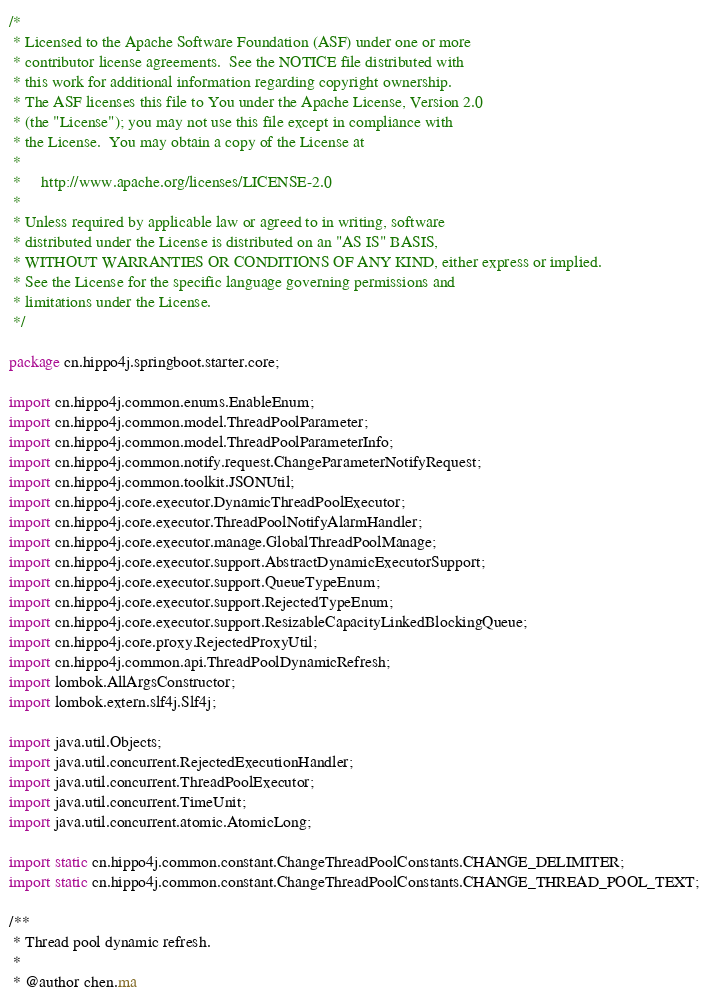Convert code to text. <code><loc_0><loc_0><loc_500><loc_500><_Java_>/*
 * Licensed to the Apache Software Foundation (ASF) under one or more
 * contributor license agreements.  See the NOTICE file distributed with
 * this work for additional information regarding copyright ownership.
 * The ASF licenses this file to You under the Apache License, Version 2.0
 * (the "License"); you may not use this file except in compliance with
 * the License.  You may obtain a copy of the License at
 *
 *     http://www.apache.org/licenses/LICENSE-2.0
 *
 * Unless required by applicable law or agreed to in writing, software
 * distributed under the License is distributed on an "AS IS" BASIS,
 * WITHOUT WARRANTIES OR CONDITIONS OF ANY KIND, either express or implied.
 * See the License for the specific language governing permissions and
 * limitations under the License.
 */

package cn.hippo4j.springboot.starter.core;

import cn.hippo4j.common.enums.EnableEnum;
import cn.hippo4j.common.model.ThreadPoolParameter;
import cn.hippo4j.common.model.ThreadPoolParameterInfo;
import cn.hippo4j.common.notify.request.ChangeParameterNotifyRequest;
import cn.hippo4j.common.toolkit.JSONUtil;
import cn.hippo4j.core.executor.DynamicThreadPoolExecutor;
import cn.hippo4j.core.executor.ThreadPoolNotifyAlarmHandler;
import cn.hippo4j.core.executor.manage.GlobalThreadPoolManage;
import cn.hippo4j.core.executor.support.AbstractDynamicExecutorSupport;
import cn.hippo4j.core.executor.support.QueueTypeEnum;
import cn.hippo4j.core.executor.support.RejectedTypeEnum;
import cn.hippo4j.core.executor.support.ResizableCapacityLinkedBlockingQueue;
import cn.hippo4j.core.proxy.RejectedProxyUtil;
import cn.hippo4j.common.api.ThreadPoolDynamicRefresh;
import lombok.AllArgsConstructor;
import lombok.extern.slf4j.Slf4j;

import java.util.Objects;
import java.util.concurrent.RejectedExecutionHandler;
import java.util.concurrent.ThreadPoolExecutor;
import java.util.concurrent.TimeUnit;
import java.util.concurrent.atomic.AtomicLong;

import static cn.hippo4j.common.constant.ChangeThreadPoolConstants.CHANGE_DELIMITER;
import static cn.hippo4j.common.constant.ChangeThreadPoolConstants.CHANGE_THREAD_POOL_TEXT;

/**
 * Thread pool dynamic refresh.
 *
 * @author chen.ma</code> 